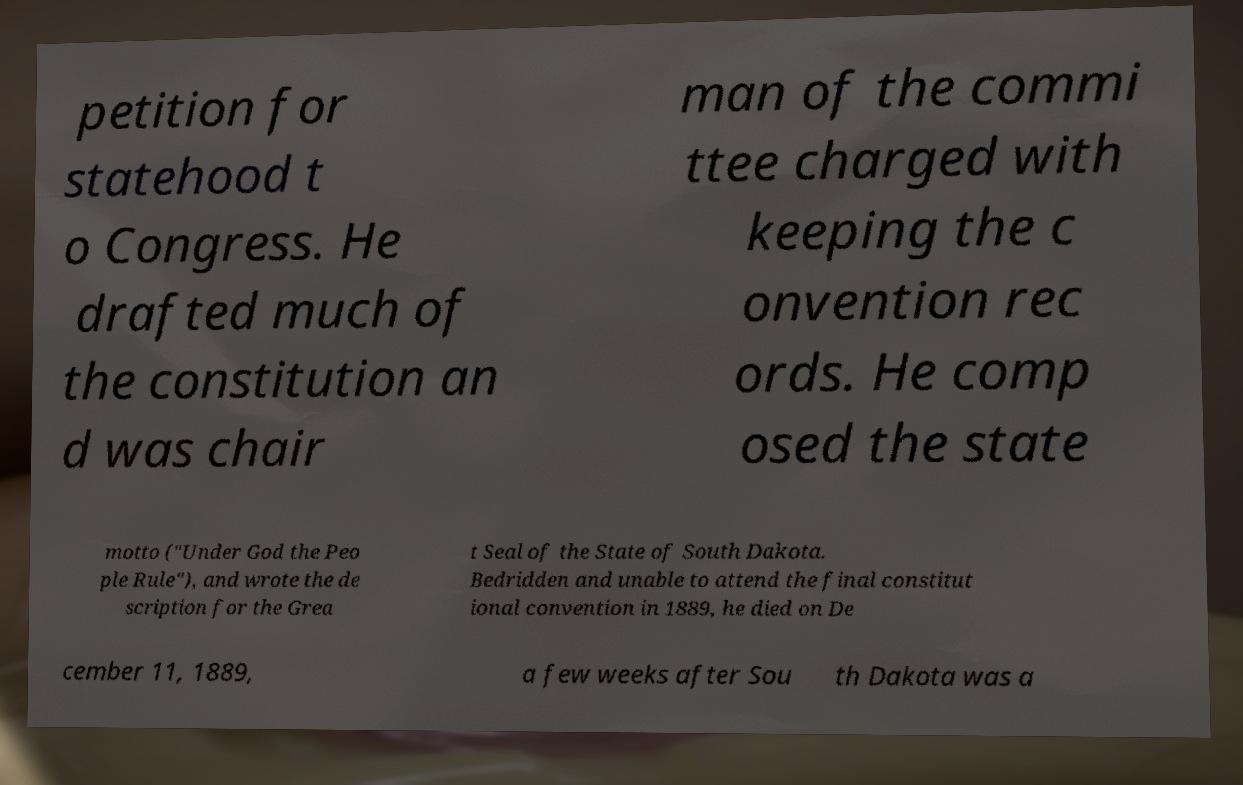Can you read and provide the text displayed in the image?This photo seems to have some interesting text. Can you extract and type it out for me? petition for statehood t o Congress. He drafted much of the constitution an d was chair man of the commi ttee charged with keeping the c onvention rec ords. He comp osed the state motto ("Under God the Peo ple Rule"), and wrote the de scription for the Grea t Seal of the State of South Dakota. Bedridden and unable to attend the final constitut ional convention in 1889, he died on De cember 11, 1889, a few weeks after Sou th Dakota was a 